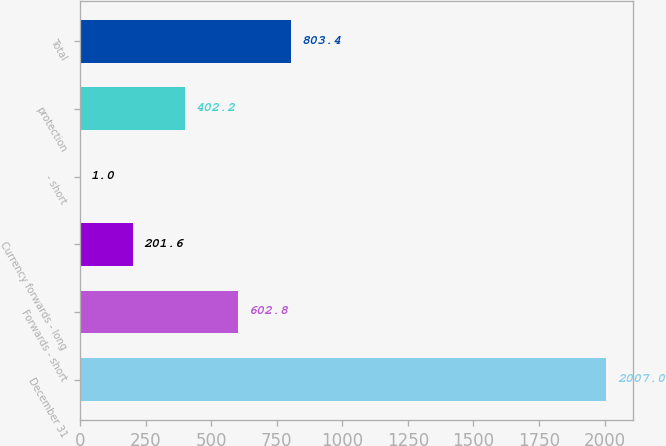Convert chart to OTSL. <chart><loc_0><loc_0><loc_500><loc_500><bar_chart><fcel>December 31<fcel>Forwards - short<fcel>Currency forwards - long<fcel>- short<fcel>protection<fcel>Total<nl><fcel>2007<fcel>602.8<fcel>201.6<fcel>1<fcel>402.2<fcel>803.4<nl></chart> 